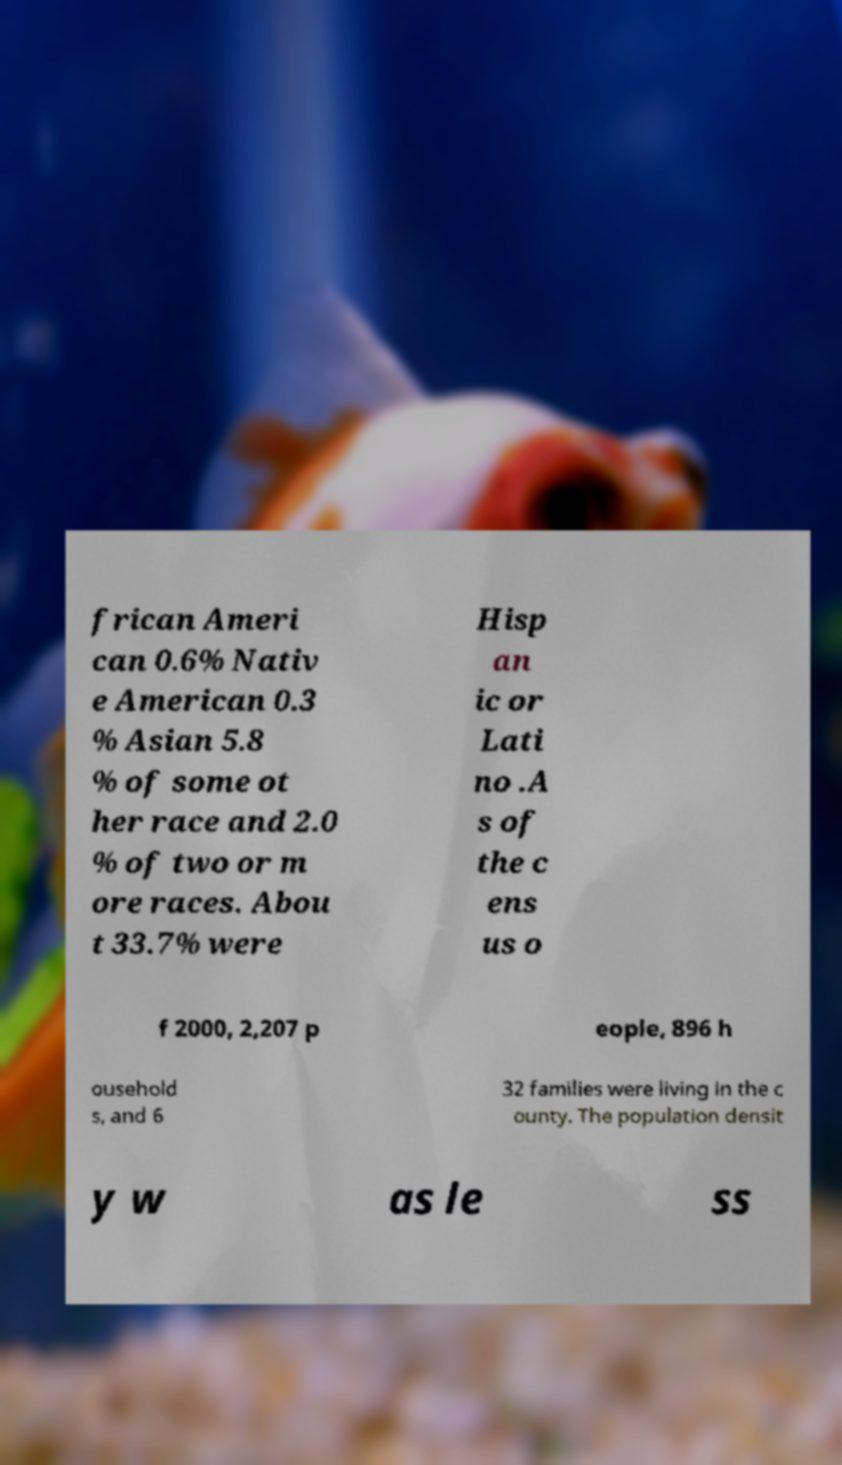What messages or text are displayed in this image? I need them in a readable, typed format. frican Ameri can 0.6% Nativ e American 0.3 % Asian 5.8 % of some ot her race and 2.0 % of two or m ore races. Abou t 33.7% were Hisp an ic or Lati no .A s of the c ens us o f 2000, 2,207 p eople, 896 h ousehold s, and 6 32 families were living in the c ounty. The population densit y w as le ss 